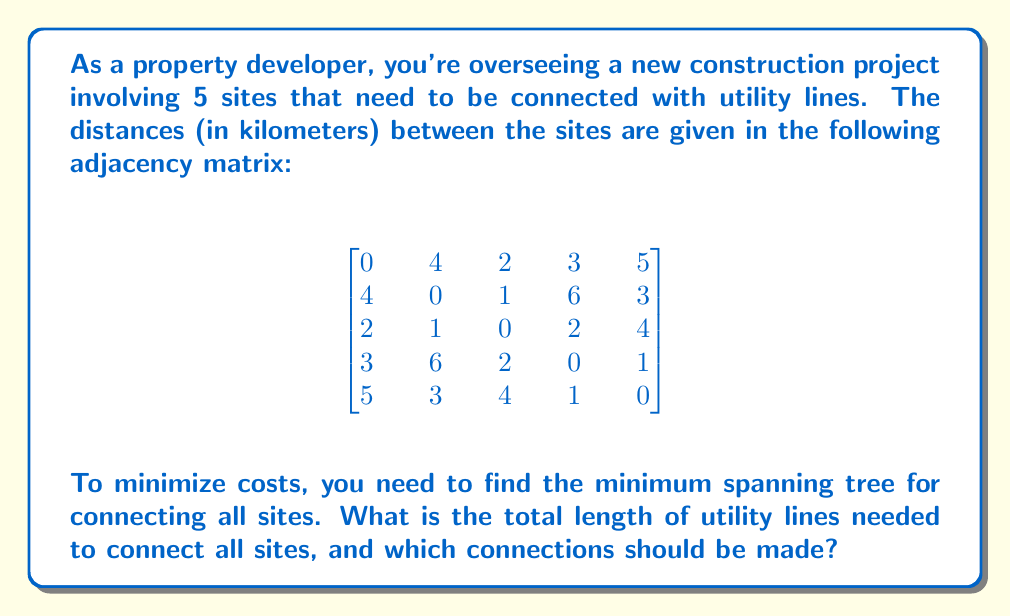Give your solution to this math problem. To solve this problem, we'll use Kruskal's algorithm to find the minimum spanning tree (MST) of the graph represented by the adjacency matrix. Here's the step-by-step process:

1. List all edges and their weights in ascending order:
   (2,3): 1
   (3,5): 1
   (1,3): 2
   (3,4): 2
   (2,5): 3
   (1,4): 3
   (1,2): 4
   (2,4): 6
   (1,5): 5

2. Initialize a forest with each vertex in its own tree.

3. Iterate through the sorted edges:
   a. (2,3): 1 - Add to MST, connect vertices 2 and 3
   b. (3,5): 1 - Add to MST, connect vertices 3 and 5
   c. (1,3): 2 - Add to MST, connect vertices 1 and 3
   d. (3,4): 2 - Add to MST, connect vertices 3 and 4

4. Stop as we have added 4 edges, which is sufficient for a MST in a graph with 5 vertices.

The resulting minimum spanning tree has the following edges:
- Site 2 to Site 3: 1 km
- Site 3 to Site 5: 1 km
- Site 1 to Site 3: 2 km
- Site 3 to Site 4: 2 km

The total length of utility lines needed is the sum of these distances: 1 + 1 + 2 + 2 = 6 km.

[asy]
unitsize(30);
pair[] vertices = {(0,0), (2,0), (1,1.732), (-1,1.732), (-2,0)};
draw(vertices[0]--vertices[2], blue+linewidth(1));
draw(vertices[1]--vertices[2], blue+linewidth(1));
draw(vertices[2]--vertices[3], blue+linewidth(1));
draw(vertices[2]--vertices[4], blue+linewidth(1));
for(int i=0; i<5; ++i) {
    dot(vertices[i], red);
    label(string(i+1), vertices[i], (i==2 ? S : i<2 ? N : NE));
}
[/asy]
Answer: The minimum total length of utility lines needed is 6 km. The connections should be made between:
1. Site 2 and Site 3
2. Site 3 and Site 5
3. Site 1 and Site 3
4. Site 3 and Site 4 